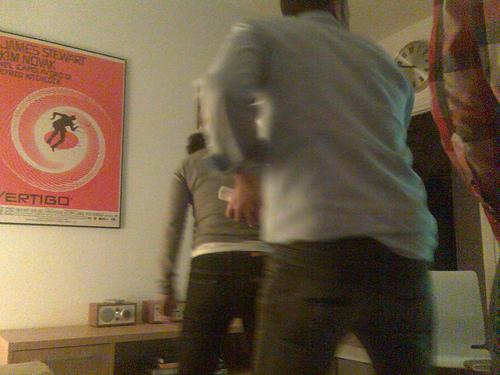What form of vintage media do the people in the living room enjoy?

Choices:
A) music
B) movies
C) paintings
D) books movies 